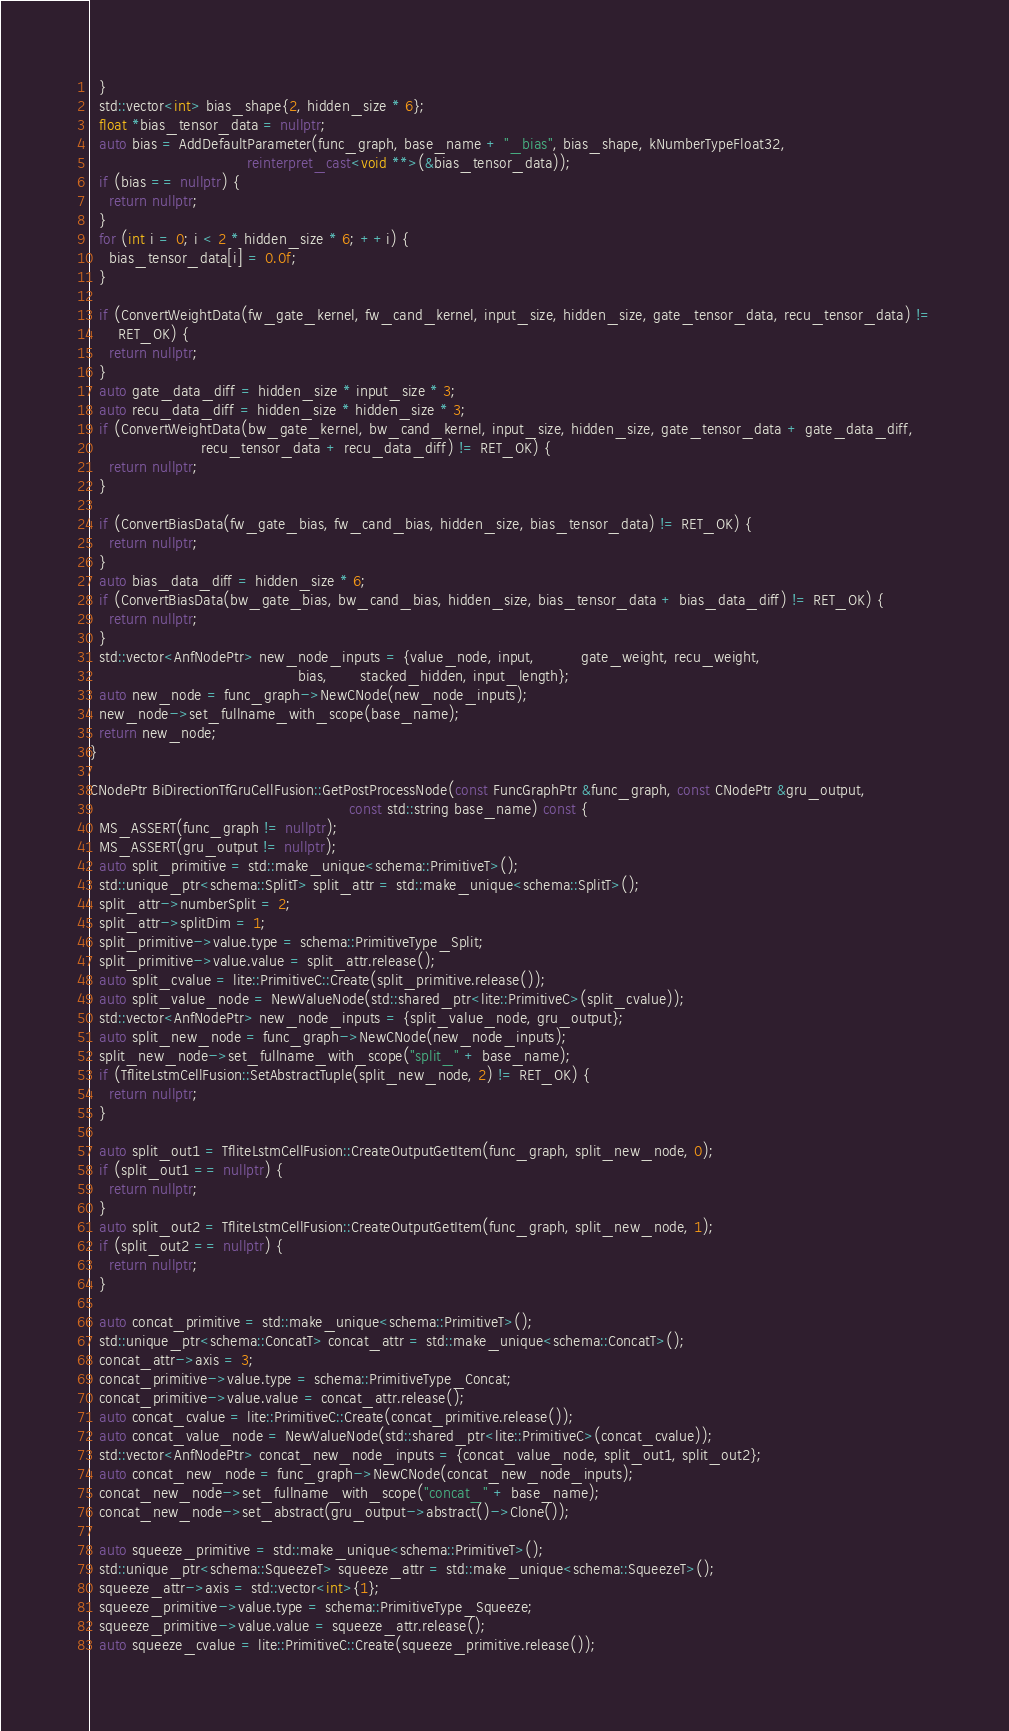<code> <loc_0><loc_0><loc_500><loc_500><_C++_>  }
  std::vector<int> bias_shape{2, hidden_size * 6};
  float *bias_tensor_data = nullptr;
  auto bias = AddDefaultParameter(func_graph, base_name + "_bias", bias_shape, kNumberTypeFloat32,
                                  reinterpret_cast<void **>(&bias_tensor_data));
  if (bias == nullptr) {
    return nullptr;
  }
  for (int i = 0; i < 2 * hidden_size * 6; ++i) {
    bias_tensor_data[i] = 0.0f;
  }

  if (ConvertWeightData(fw_gate_kernel, fw_cand_kernel, input_size, hidden_size, gate_tensor_data, recu_tensor_data) !=
      RET_OK) {
    return nullptr;
  }
  auto gate_data_diff = hidden_size * input_size * 3;
  auto recu_data_diff = hidden_size * hidden_size * 3;
  if (ConvertWeightData(bw_gate_kernel, bw_cand_kernel, input_size, hidden_size, gate_tensor_data + gate_data_diff,
                        recu_tensor_data + recu_data_diff) != RET_OK) {
    return nullptr;
  }

  if (ConvertBiasData(fw_gate_bias, fw_cand_bias, hidden_size, bias_tensor_data) != RET_OK) {
    return nullptr;
  }
  auto bias_data_diff = hidden_size * 6;
  if (ConvertBiasData(bw_gate_bias, bw_cand_bias, hidden_size, bias_tensor_data + bias_data_diff) != RET_OK) {
    return nullptr;
  }
  std::vector<AnfNodePtr> new_node_inputs = {value_node, input,          gate_weight, recu_weight,
                                             bias,       stacked_hidden, input_length};
  auto new_node = func_graph->NewCNode(new_node_inputs);
  new_node->set_fullname_with_scope(base_name);
  return new_node;
}

CNodePtr BiDirectionTfGruCellFusion::GetPostProcessNode(const FuncGraphPtr &func_graph, const CNodePtr &gru_output,
                                                        const std::string base_name) const {
  MS_ASSERT(func_graph != nullptr);
  MS_ASSERT(gru_output != nullptr);
  auto split_primitive = std::make_unique<schema::PrimitiveT>();
  std::unique_ptr<schema::SplitT> split_attr = std::make_unique<schema::SplitT>();
  split_attr->numberSplit = 2;
  split_attr->splitDim = 1;
  split_primitive->value.type = schema::PrimitiveType_Split;
  split_primitive->value.value = split_attr.release();
  auto split_cvalue = lite::PrimitiveC::Create(split_primitive.release());
  auto split_value_node = NewValueNode(std::shared_ptr<lite::PrimitiveC>(split_cvalue));
  std::vector<AnfNodePtr> new_node_inputs = {split_value_node, gru_output};
  auto split_new_node = func_graph->NewCNode(new_node_inputs);
  split_new_node->set_fullname_with_scope("split_" + base_name);
  if (TfliteLstmCellFusion::SetAbstractTuple(split_new_node, 2) != RET_OK) {
    return nullptr;
  }

  auto split_out1 = TfliteLstmCellFusion::CreateOutputGetItem(func_graph, split_new_node, 0);
  if (split_out1 == nullptr) {
    return nullptr;
  }
  auto split_out2 = TfliteLstmCellFusion::CreateOutputGetItem(func_graph, split_new_node, 1);
  if (split_out2 == nullptr) {
    return nullptr;
  }

  auto concat_primitive = std::make_unique<schema::PrimitiveT>();
  std::unique_ptr<schema::ConcatT> concat_attr = std::make_unique<schema::ConcatT>();
  concat_attr->axis = 3;
  concat_primitive->value.type = schema::PrimitiveType_Concat;
  concat_primitive->value.value = concat_attr.release();
  auto concat_cvalue = lite::PrimitiveC::Create(concat_primitive.release());
  auto concat_value_node = NewValueNode(std::shared_ptr<lite::PrimitiveC>(concat_cvalue));
  std::vector<AnfNodePtr> concat_new_node_inputs = {concat_value_node, split_out1, split_out2};
  auto concat_new_node = func_graph->NewCNode(concat_new_node_inputs);
  concat_new_node->set_fullname_with_scope("concat_" + base_name);
  concat_new_node->set_abstract(gru_output->abstract()->Clone());

  auto squeeze_primitive = std::make_unique<schema::PrimitiveT>();
  std::unique_ptr<schema::SqueezeT> squeeze_attr = std::make_unique<schema::SqueezeT>();
  squeeze_attr->axis = std::vector<int>{1};
  squeeze_primitive->value.type = schema::PrimitiveType_Squeeze;
  squeeze_primitive->value.value = squeeze_attr.release();
  auto squeeze_cvalue = lite::PrimitiveC::Create(squeeze_primitive.release());</code> 